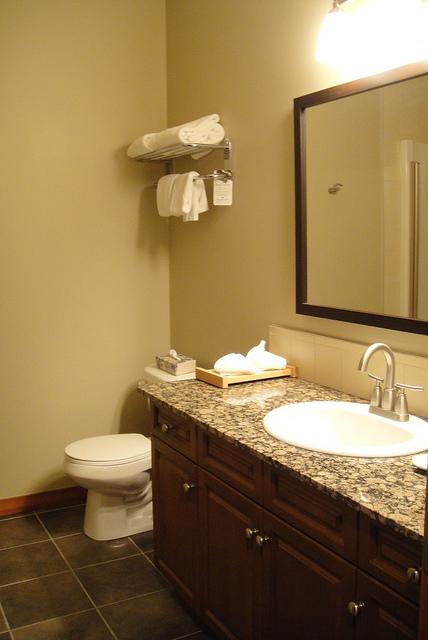Where is the toilet paper dispenser?
Concise answer only. By toilet. How many towels are there?
Write a very short answer. 4. What room is this?
Quick response, please. Bathroom. 